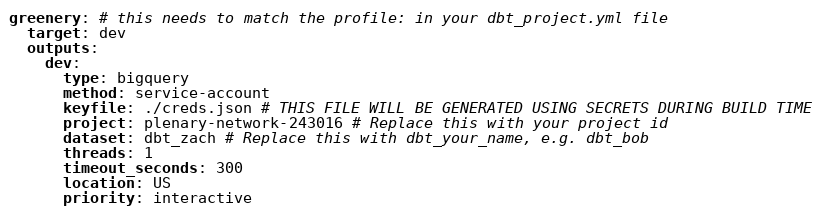<code> <loc_0><loc_0><loc_500><loc_500><_YAML_>greenery: # this needs to match the profile: in your dbt_project.yml file
  target: dev
  outputs:
    dev:
      type: bigquery
      method: service-account
      keyfile: ./creds.json # THIS FILE WILL BE GENERATED USING SECRETS DURING BUILD TIME
      project: plenary-network-243016 # Replace this with your project id
      dataset: dbt_zach # Replace this with dbt_your_name, e.g. dbt_bob
      threads: 1
      timeout_seconds: 300
      location: US
      priority: interactive</code> 